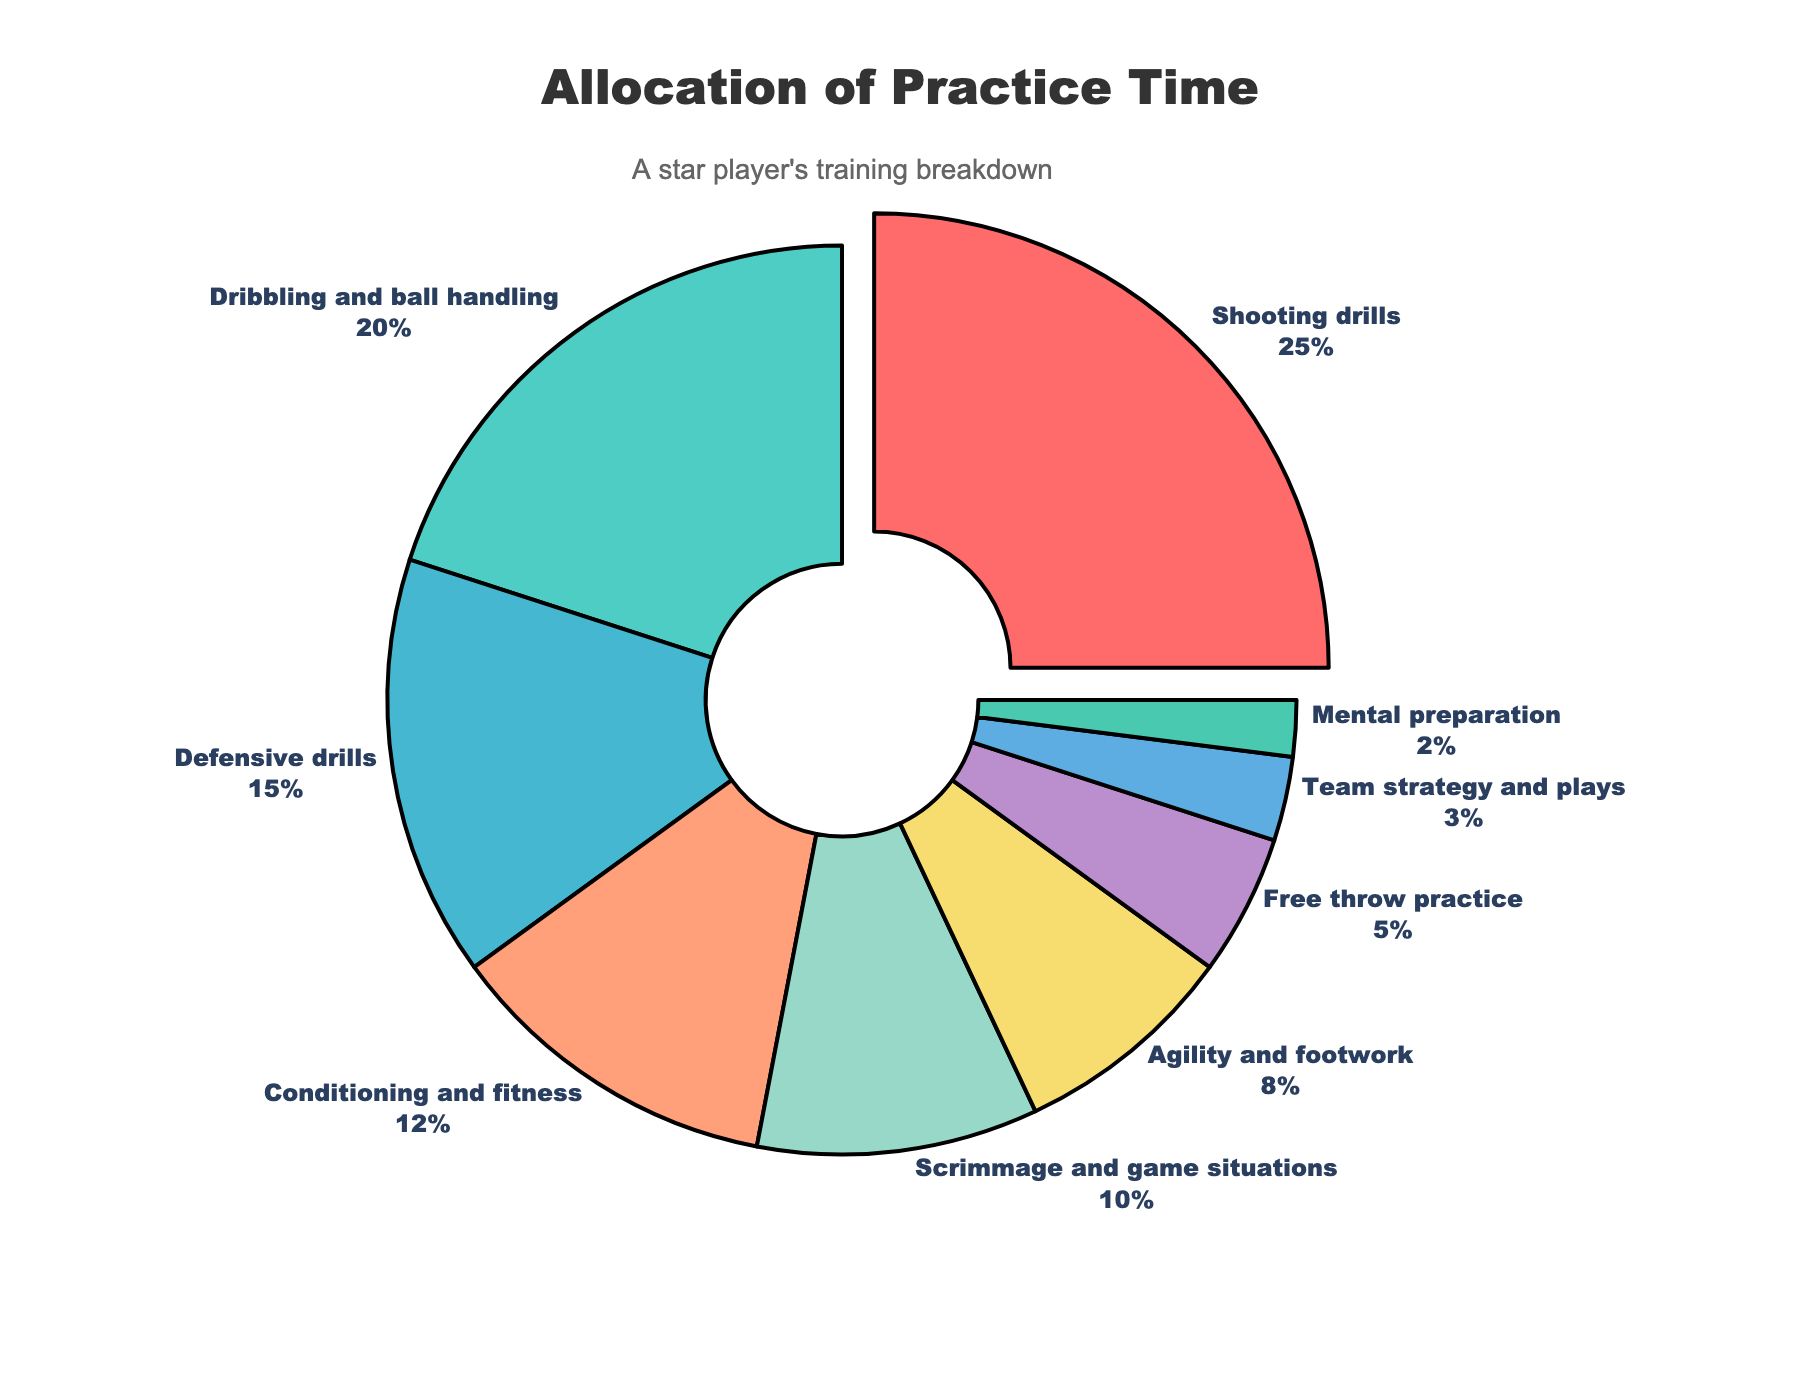Which skill receives the most practice time? The figure shows the Allocation of Practice Time where each skill is represented by a slice of the pie chart. The label 'Shooting drills' has the highest percentage of 25%, which is the largest slice.
Answer: Shooting drills What is the combined percentage of time allocated to Conditioning and fitness and Agility and footwork? To calculate the combined percentage, sum the percentages for the two skills from the pie chart: 12% (Conditioning and fitness) + 8% (Agility and footwork) = 20%.
Answer: 20% Which skill receives more practice time, Scrimmage and game situations or Free throw practice? By comparing the percentages on the pie chart, Scrimmage and game situations have 10% and Free throw practice has 5%. Since 10% is greater than 5%, Scrimmage and game situations receive more practice time.
Answer: Scrimmage and game situations What is the difference in practice time between Dribbling and ball handling and Defensive drills? To find the difference, subtract the percentage of Defensive drills from Dribbling and ball handling: 20% - 15% = 5%.
Answer: 5% How much percentage of practice time is allocated to skills other than Shooting drills, Dribbling and ball handling, and Defensive drills? First, sum the percentages of the three specified skills: 25% (Shooting drills) + 20% (Dribbling and ball handling) + 15% (Defensive drills) = 60%. Then subtract this from 100% to get the percentage of remaining skills: 100% - 60% = 40%.
Answer: 40% Which skill has the smallest allocation of practice time? The pie chart shows that 'Mental preparation' has the smallest percentage at 2%.
Answer: Mental preparation What is the combined percentage of practice time dedicated to both physical and mental preparation skills? The physical skills include Conditioning and fitness (12%), Agility and footwork (8%), and Mental preparation (2%). Summing these gives 12% + 8% + 2% = 22%.
Answer: 22% Is the time spent on Shooting drills greater than the sum of the time spent on Free throw practice and Team strategy and plays? First, sum the percentages for Free throw practice and Team strategy and plays: 5% + 3% = 8%. The percentage for Shooting drills is 25%. Since 25% > 8%, the time spent on Shooting drills is greater.
Answer: Yes What is the average percentage of practice time spent on Defensive drills, Conditioning and fitness, and Free throw practice? Sum the percentages for the three skills: 15% (Defensive drills) + 12% (Conditioning and fitness) + 5% (Free throw practice) = 32%. Then, divide by the number of skills: 32% / 3 ≈ 10.67%.
Answer: 10.67% 